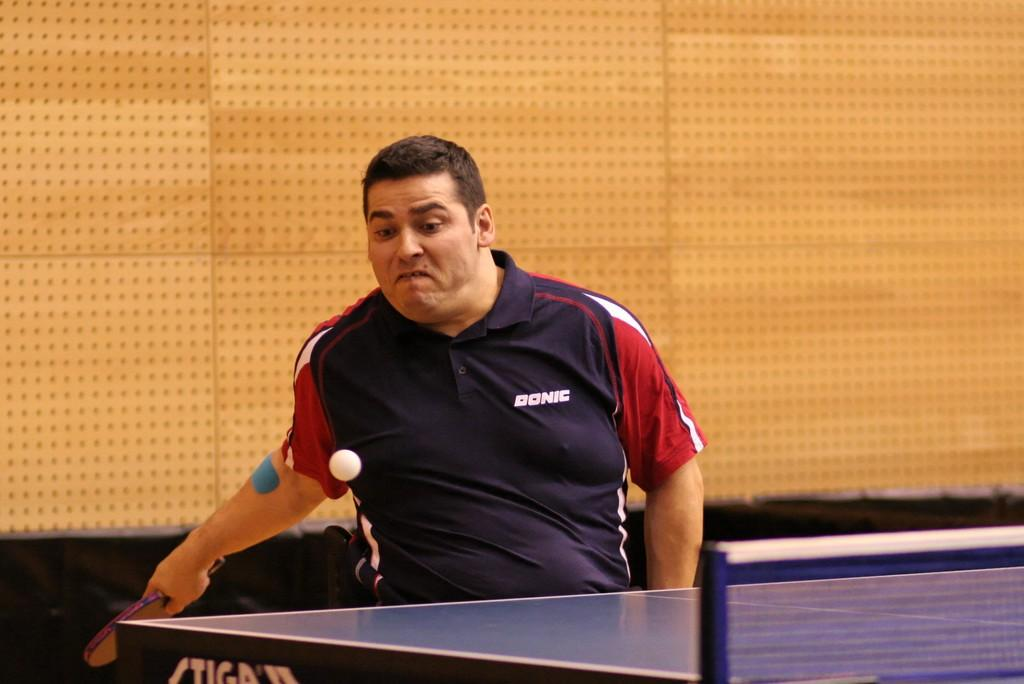What is the main subject of the image? There is a person in the image. What is the person wearing? The person is wearing a blue shirt. What activity is the person engaged in? The person is playing table tennis. What type of industry can be seen in the background of the image? There is no industry visible in the image; it only features a person playing table tennis. How many legs does the can have in the image? There is no can present in the image, so it is not possible to determine the number of legs it might have. 